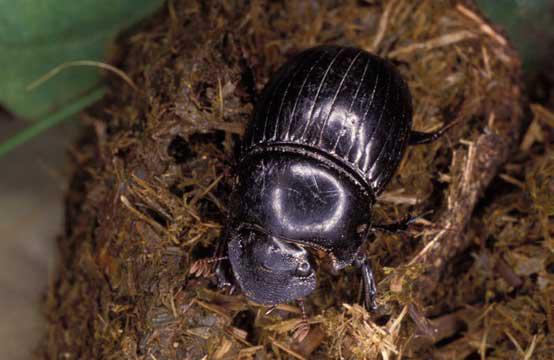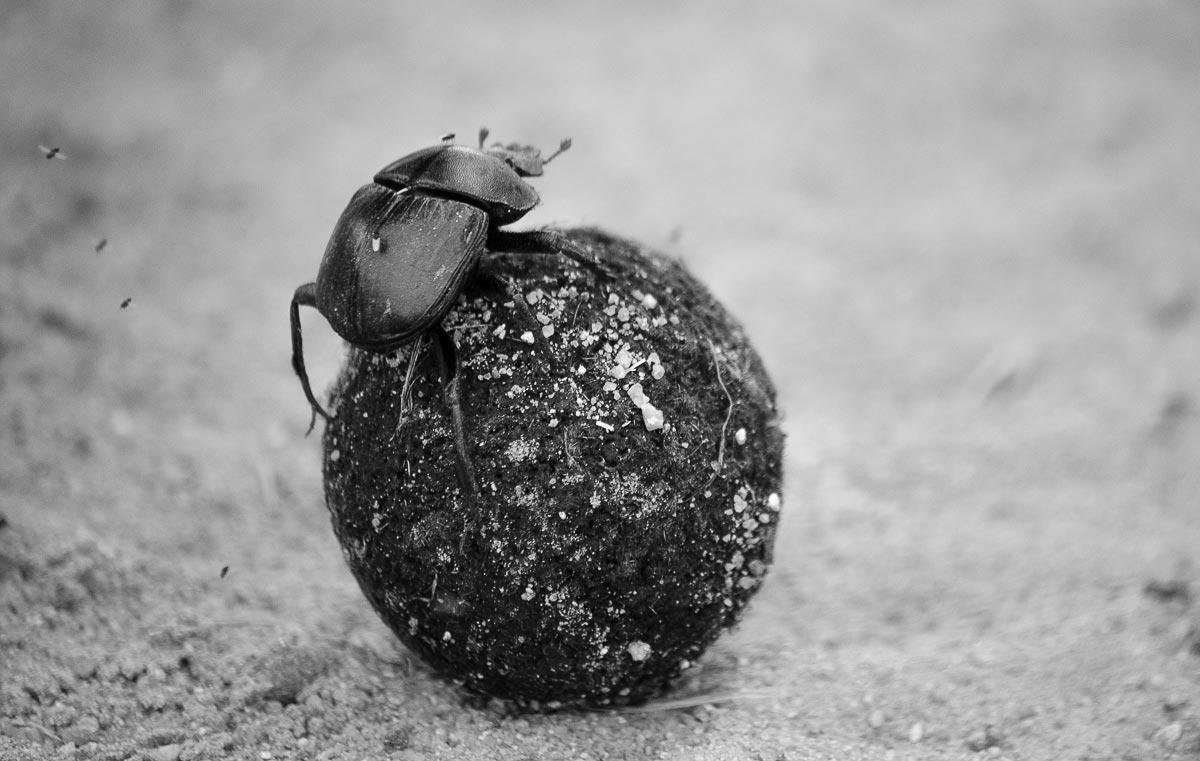The first image is the image on the left, the second image is the image on the right. For the images shown, is this caption "One image shows one beetle in contact with a round shape, and the other image includes a mass of small dark round things." true? Answer yes or no. No. The first image is the image on the left, the second image is the image on the right. For the images displayed, is the sentence "A beetle is in the 11 o'clock position on top of a dung ball." factually correct? Answer yes or no. Yes. 